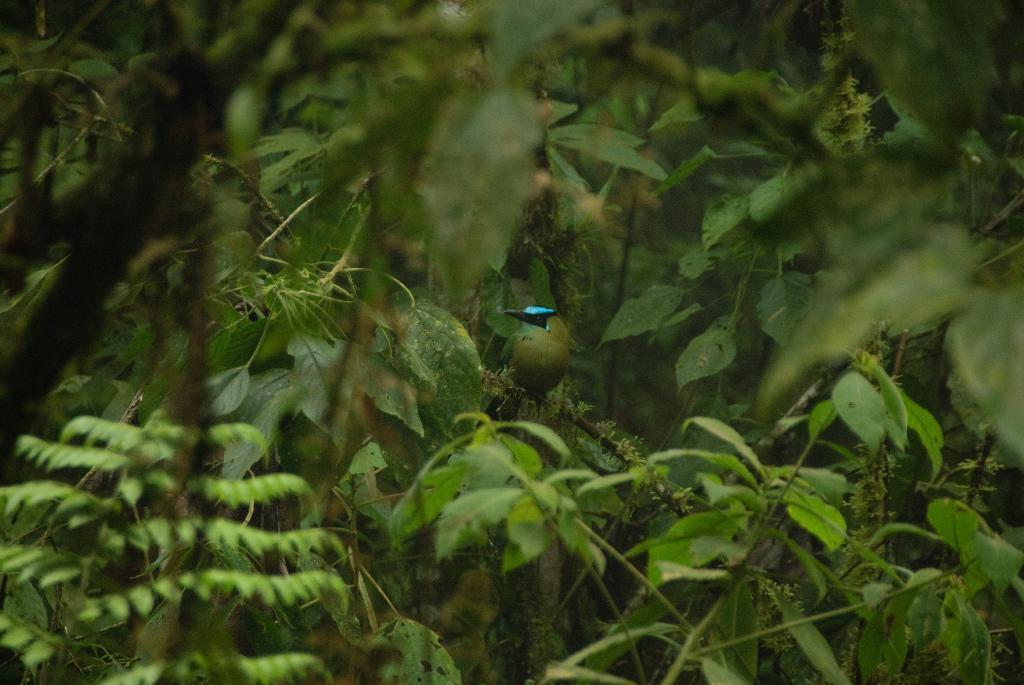Can you describe this image briefly? A bird is sitting on the green color tree. 